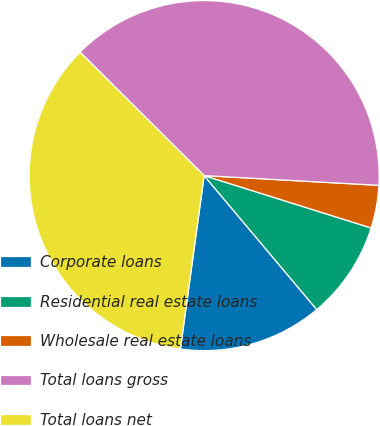Convert chart to OTSL. <chart><loc_0><loc_0><loc_500><loc_500><pie_chart><fcel>Corporate loans<fcel>Residential real estate loans<fcel>Wholesale real estate loans<fcel>Total loans gross<fcel>Total loans net<nl><fcel>13.29%<fcel>9.04%<fcel>3.95%<fcel>38.43%<fcel>35.29%<nl></chart> 